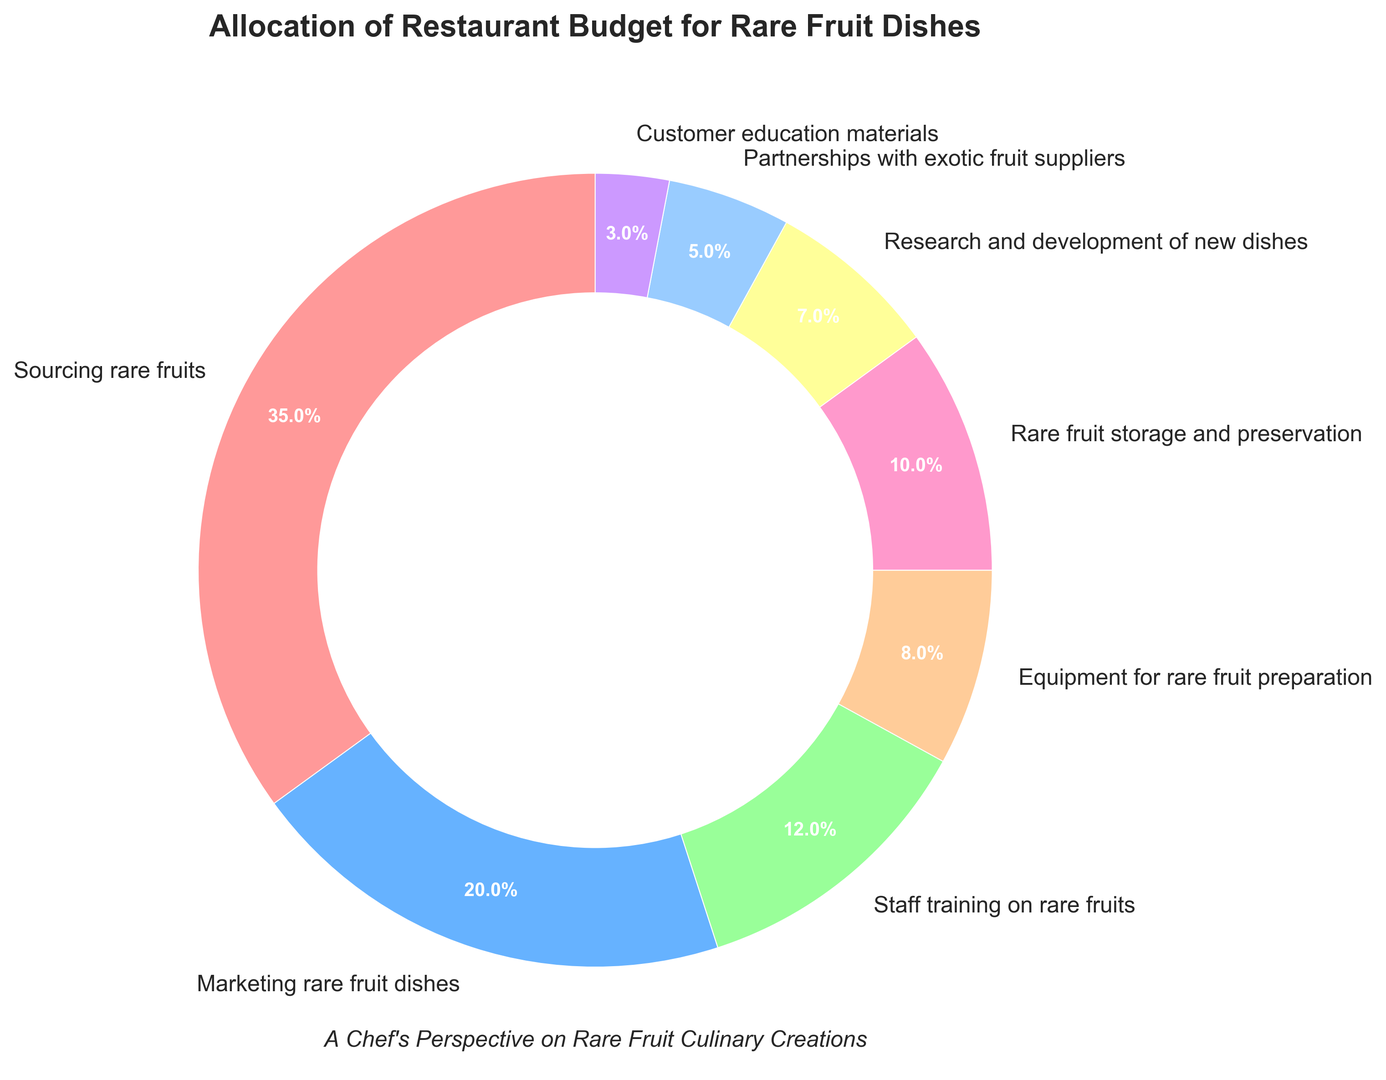what category has the highest budget allocation? The wedge representing "Sourcing rare fruits" is the largest and is labeled 35%, which is the highest percentage.
Answer: Sourcing rare fruits how much more is the budget allocation for sourcing rare fruits compared to marketing rare fruit dishes? The pie chart shows "Sourcing rare fruits" at 35% and "Marketing rare fruit dishes" at 20%. The difference is 35% - 20% = 15%.
Answer: 15% what categories have budget allocations less than 10%? According to the pie chart, the categories with less than 10% allocation are "Equipment for rare fruit preparation" (8%), "Rare fruit storage and preservation" (10%), "Research and development of new dishes" (7%), "Partnerships with exotic fruit suppliers" (5%), and "Customer education materials" (3%).
Answer: Equipment for rare fruit preparation, Rare fruit storage and preservation, Research and development of new dishes, Partnerships with exotic fruit suppliers, Customer education materials what is the combined budget allocation for both marketing rare fruit dishes and staff training on rare fruits? The pie chart shows "Marketing rare fruit dishes" at 20% and "Staff training on rare fruits" at 12%. Combined allocation is 20% + 12% = 32%.
Answer: 32% how does the budget allocation for partnerships with exotic fruit suppliers compare to customer education materials? The chart shows "Partnerships with exotic fruit suppliers" at 5% and "Customer education materials" at 3%. 5% is greater than 3%.
Answer: Partnerships with exotic fruit suppliers have a higher budget allocation which segment of the pie chart is represented in yellow? Observing the color distribution in the pie chart, the only segment in yellow is labeled "Research and development of new dishes" at 7%.
Answer: Research and development of new dishes how many categories have a budget allocation of at least 10%? From the pie chart: "Sourcing rare fruits" (35%), "Marketing rare fruit dishes" (20%), "Staff training on rare fruits" (12%), "Rare fruit storage and preservation" (10%). This totals to four categories.
Answer: 4 is the budget more focused on sourcing and marketing or on equipment and storage? Sourcing and marketing allocations are 35% + 20% = 55%. Equipment and storage allocations are 8% + 10% = 18%. 55% is greater, indicating more focus on sourcing and marketing.
Answer: Sourcing and marketing what percentage of the budget is allocated to activities directly related to handling rare fruits (sourcing, storage, preparation training)? Combining the categories: "Sourcing rare fruits" (35%), "Rare fruit storage and preservation" (10%), "Equipment for rare fruit preparation" (8%), and "Staff training on rare fruits" (12%). The sum is 35% + 10% + 8% + 12% = 65%.
Answer: 65% which category has the smallest budget allocation and what is it? The smallest wedge in the pie chart is labeled "Customer education materials" with 3%.
Answer: Customer education materials, 3% 